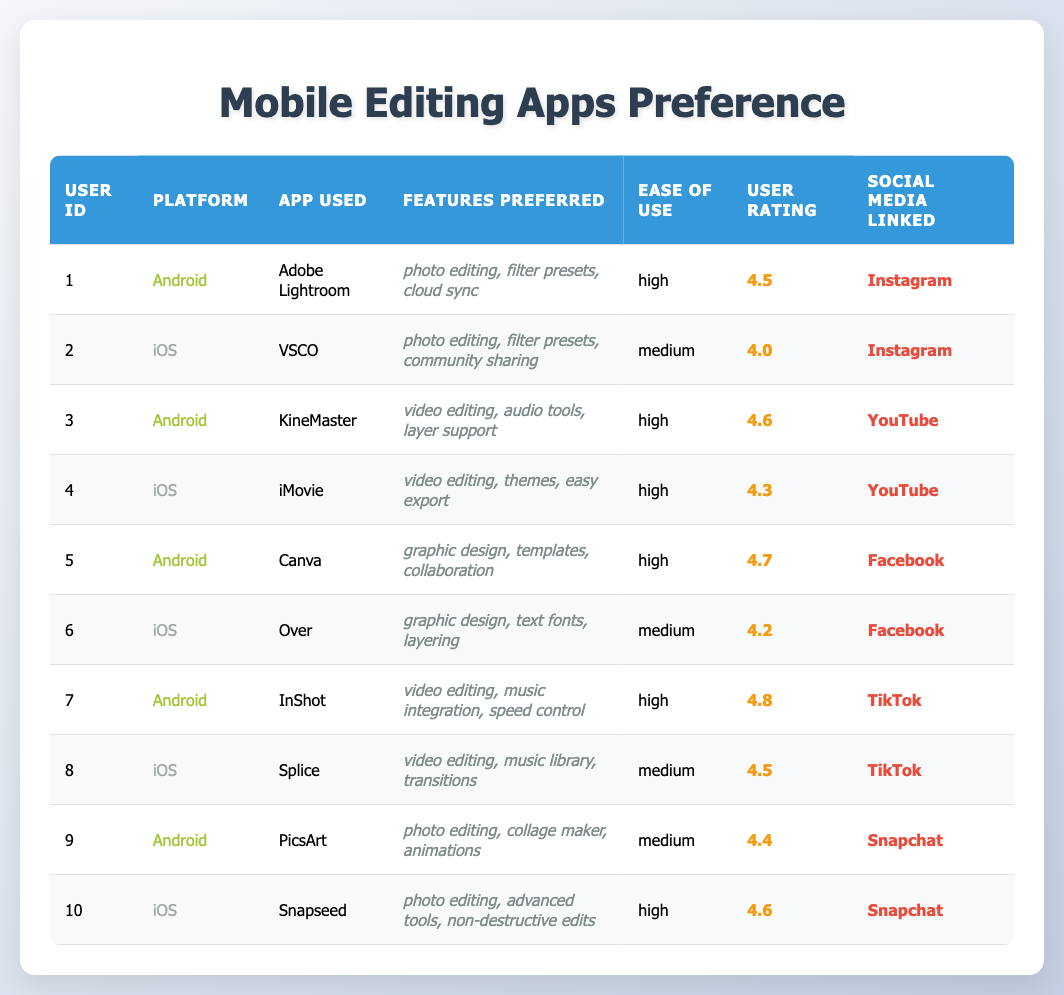What is the highest user rating among the Android apps listed? By looking through the ratings for all Android apps in the table, I find that KineMaster has a rating of 4.6, InShot has a rating of 4.8, and Adobe Lightroom has a rating of 4.5. The highest rating is therefore from InShot.
Answer: 4.8 Which iOS app has the highest user rating? Scanning through the iOS app ratings, I see that Snapseed has a rating of 4.6, iMovie has a rating of 4.3, and VSCO has a rating of 4.0. Snapseed has the highest rating among them.
Answer: Snapseed How many Android users rated their apps with a score of 4.5 or higher? I will count the Android users with ratings of 4.5 and above, which are KineMaster (4.6), InShot (4.8), Adobe Lightroom (4.5), and Canva (4.7). There are a total of four users.
Answer: 4 Is there any app used on both platforms with similar features? Reviewing the features of apps on both platforms, Adobe Lightroom and Snapseed both emphasize photo editing, among other features. Although they are different apps, they share a focus on photo editing.
Answer: Yes What is the average user rating for the Android apps? To find the average rating, I will sum the ratings of all Android apps: 4.5 (Adobe Lightroom) + 4.6 (KineMaster) + 4.7 (Canva) + 4.8 (InShot) + 4.4 (PicsArt) = 24.0. There are 5 Android apps, so the average is 24.0 / 5 = 4.8.
Answer: 4.8 How many iOS users have linked their apps to TikTok? I will check the social media linked by iOS users in the table and see that Splice is linked to TikTok. Only one user has linked their app to TikTok.
Answer: 1 Which platform has more users with high ease of use? Counting ease of use ratings, Android has 4 users who rated their apps as high (Adobe Lightroom, KineMaster, Canva, InShot), while iOS has 4 users (VSCO, iMovie, Over, Snapseed). Both platforms have the same number of users with high ease of use ratings.
Answer: Equal What are the preferred features for the iOS app "Over"? The features preferred for "Over" are graphic design, text fonts, and layering as mentioned in the corresponding row.
Answer: graphic design, text fonts, layering How many users use photo editing apps? I will look through the apps for both platforms and find that Adobe Lightroom, VSCO, PicsArt, and Snapseed are all photo editing apps. I count a total of 4 users.
Answer: 4 